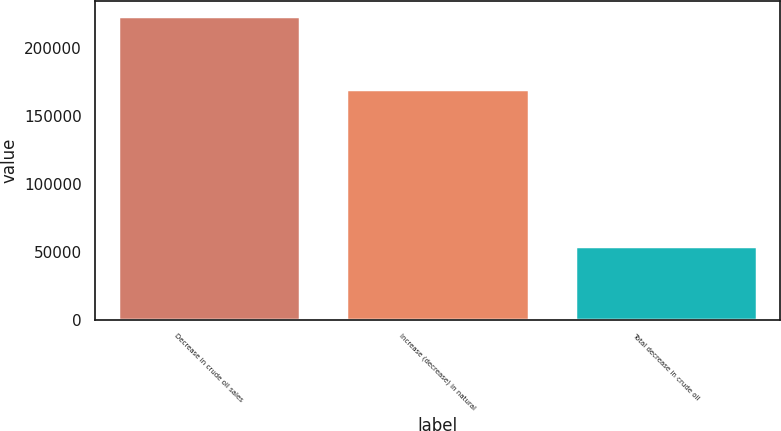Convert chart to OTSL. <chart><loc_0><loc_0><loc_500><loc_500><bar_chart><fcel>Decrease in crude oil sales<fcel>Increase (decrease) in natural<fcel>Total decrease in crude oil<nl><fcel>223347<fcel>169242<fcel>54105<nl></chart> 